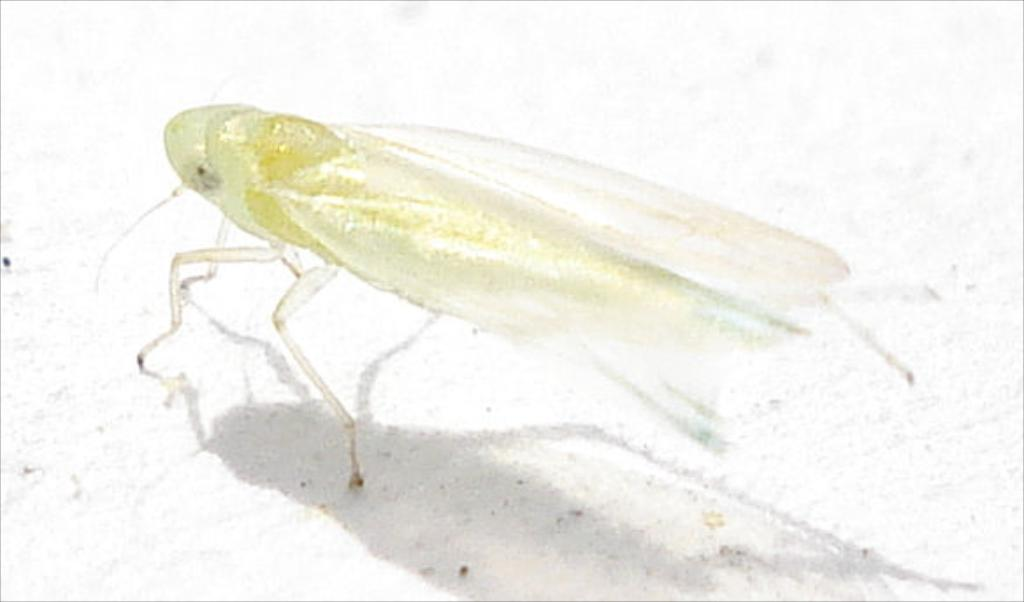What type of creature is present in the image? There is an insect in the image. What color is the background of the image? The background of the image appears to be white. What type of square is visible in the image? There is no square present in the image. What team is associated with the insect in the image? There is no team associated with the insect in the image. 